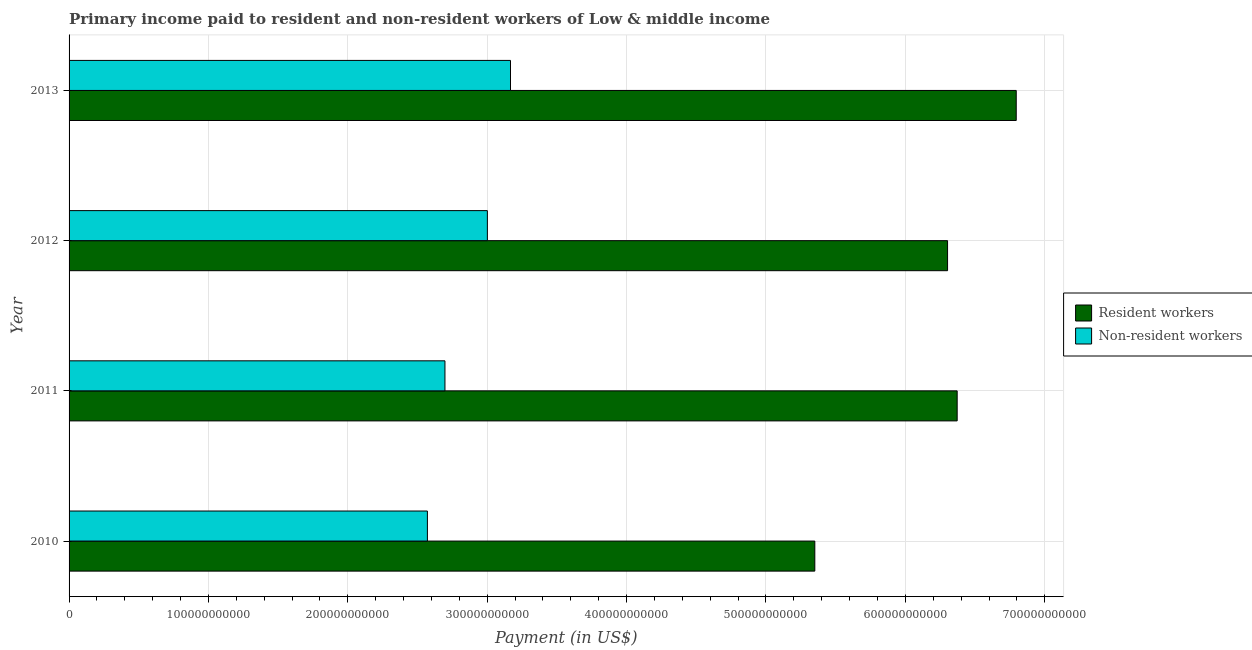How many different coloured bars are there?
Your answer should be very brief. 2. Are the number of bars per tick equal to the number of legend labels?
Offer a very short reply. Yes. Are the number of bars on each tick of the Y-axis equal?
Provide a short and direct response. Yes. How many bars are there on the 3rd tick from the top?
Provide a succinct answer. 2. In how many cases, is the number of bars for a given year not equal to the number of legend labels?
Your answer should be compact. 0. What is the payment made to non-resident workers in 2011?
Make the answer very short. 2.70e+11. Across all years, what is the maximum payment made to non-resident workers?
Ensure brevity in your answer.  3.17e+11. Across all years, what is the minimum payment made to resident workers?
Ensure brevity in your answer.  5.35e+11. In which year was the payment made to non-resident workers maximum?
Give a very brief answer. 2013. In which year was the payment made to non-resident workers minimum?
Your answer should be compact. 2010. What is the total payment made to non-resident workers in the graph?
Your answer should be very brief. 1.14e+12. What is the difference between the payment made to non-resident workers in 2012 and that in 2013?
Your answer should be very brief. -1.66e+1. What is the difference between the payment made to non-resident workers in 2010 and the payment made to resident workers in 2011?
Your answer should be compact. -3.80e+11. What is the average payment made to non-resident workers per year?
Offer a very short reply. 2.86e+11. In the year 2010, what is the difference between the payment made to resident workers and payment made to non-resident workers?
Your answer should be very brief. 2.78e+11. In how many years, is the payment made to resident workers greater than 520000000000 US$?
Provide a short and direct response. 4. What is the ratio of the payment made to non-resident workers in 2010 to that in 2011?
Ensure brevity in your answer.  0.95. Is the payment made to non-resident workers in 2010 less than that in 2013?
Your answer should be compact. Yes. What is the difference between the highest and the second highest payment made to resident workers?
Make the answer very short. 4.24e+1. What is the difference between the highest and the lowest payment made to non-resident workers?
Give a very brief answer. 5.96e+1. In how many years, is the payment made to resident workers greater than the average payment made to resident workers taken over all years?
Give a very brief answer. 3. What does the 1st bar from the top in 2011 represents?
Make the answer very short. Non-resident workers. What does the 1st bar from the bottom in 2010 represents?
Provide a short and direct response. Resident workers. How many bars are there?
Your response must be concise. 8. Are all the bars in the graph horizontal?
Provide a succinct answer. Yes. What is the difference between two consecutive major ticks on the X-axis?
Give a very brief answer. 1.00e+11. Where does the legend appear in the graph?
Your response must be concise. Center right. How many legend labels are there?
Ensure brevity in your answer.  2. How are the legend labels stacked?
Give a very brief answer. Vertical. What is the title of the graph?
Give a very brief answer. Primary income paid to resident and non-resident workers of Low & middle income. What is the label or title of the X-axis?
Your response must be concise. Payment (in US$). What is the label or title of the Y-axis?
Give a very brief answer. Year. What is the Payment (in US$) in Resident workers in 2010?
Offer a very short reply. 5.35e+11. What is the Payment (in US$) in Non-resident workers in 2010?
Your answer should be compact. 2.57e+11. What is the Payment (in US$) in Resident workers in 2011?
Offer a very short reply. 6.37e+11. What is the Payment (in US$) in Non-resident workers in 2011?
Keep it short and to the point. 2.70e+11. What is the Payment (in US$) in Resident workers in 2012?
Your answer should be compact. 6.30e+11. What is the Payment (in US$) in Non-resident workers in 2012?
Offer a terse response. 3.00e+11. What is the Payment (in US$) of Resident workers in 2013?
Keep it short and to the point. 6.80e+11. What is the Payment (in US$) in Non-resident workers in 2013?
Give a very brief answer. 3.17e+11. Across all years, what is the maximum Payment (in US$) in Resident workers?
Make the answer very short. 6.80e+11. Across all years, what is the maximum Payment (in US$) of Non-resident workers?
Your response must be concise. 3.17e+11. Across all years, what is the minimum Payment (in US$) in Resident workers?
Offer a terse response. 5.35e+11. Across all years, what is the minimum Payment (in US$) of Non-resident workers?
Ensure brevity in your answer.  2.57e+11. What is the total Payment (in US$) of Resident workers in the graph?
Provide a short and direct response. 2.48e+12. What is the total Payment (in US$) in Non-resident workers in the graph?
Make the answer very short. 1.14e+12. What is the difference between the Payment (in US$) of Resident workers in 2010 and that in 2011?
Give a very brief answer. -1.02e+11. What is the difference between the Payment (in US$) of Non-resident workers in 2010 and that in 2011?
Offer a very short reply. -1.26e+1. What is the difference between the Payment (in US$) in Resident workers in 2010 and that in 2012?
Your answer should be very brief. -9.52e+1. What is the difference between the Payment (in US$) of Non-resident workers in 2010 and that in 2012?
Your answer should be very brief. -4.30e+1. What is the difference between the Payment (in US$) of Resident workers in 2010 and that in 2013?
Ensure brevity in your answer.  -1.45e+11. What is the difference between the Payment (in US$) in Non-resident workers in 2010 and that in 2013?
Keep it short and to the point. -5.96e+1. What is the difference between the Payment (in US$) of Resident workers in 2011 and that in 2012?
Provide a short and direct response. 6.90e+09. What is the difference between the Payment (in US$) of Non-resident workers in 2011 and that in 2012?
Offer a terse response. -3.04e+1. What is the difference between the Payment (in US$) of Resident workers in 2011 and that in 2013?
Offer a very short reply. -4.24e+1. What is the difference between the Payment (in US$) of Non-resident workers in 2011 and that in 2013?
Provide a succinct answer. -4.70e+1. What is the difference between the Payment (in US$) in Resident workers in 2012 and that in 2013?
Make the answer very short. -4.93e+1. What is the difference between the Payment (in US$) of Non-resident workers in 2012 and that in 2013?
Provide a short and direct response. -1.66e+1. What is the difference between the Payment (in US$) of Resident workers in 2010 and the Payment (in US$) of Non-resident workers in 2011?
Offer a very short reply. 2.65e+11. What is the difference between the Payment (in US$) of Resident workers in 2010 and the Payment (in US$) of Non-resident workers in 2012?
Provide a short and direct response. 2.35e+11. What is the difference between the Payment (in US$) in Resident workers in 2010 and the Payment (in US$) in Non-resident workers in 2013?
Provide a short and direct response. 2.18e+11. What is the difference between the Payment (in US$) in Resident workers in 2011 and the Payment (in US$) in Non-resident workers in 2012?
Give a very brief answer. 3.37e+11. What is the difference between the Payment (in US$) of Resident workers in 2011 and the Payment (in US$) of Non-resident workers in 2013?
Provide a succinct answer. 3.20e+11. What is the difference between the Payment (in US$) in Resident workers in 2012 and the Payment (in US$) in Non-resident workers in 2013?
Your answer should be very brief. 3.14e+11. What is the average Payment (in US$) of Resident workers per year?
Make the answer very short. 6.21e+11. What is the average Payment (in US$) in Non-resident workers per year?
Provide a short and direct response. 2.86e+11. In the year 2010, what is the difference between the Payment (in US$) in Resident workers and Payment (in US$) in Non-resident workers?
Provide a short and direct response. 2.78e+11. In the year 2011, what is the difference between the Payment (in US$) of Resident workers and Payment (in US$) of Non-resident workers?
Make the answer very short. 3.67e+11. In the year 2012, what is the difference between the Payment (in US$) of Resident workers and Payment (in US$) of Non-resident workers?
Offer a terse response. 3.30e+11. In the year 2013, what is the difference between the Payment (in US$) of Resident workers and Payment (in US$) of Non-resident workers?
Your response must be concise. 3.63e+11. What is the ratio of the Payment (in US$) of Resident workers in 2010 to that in 2011?
Ensure brevity in your answer.  0.84. What is the ratio of the Payment (in US$) in Non-resident workers in 2010 to that in 2011?
Offer a very short reply. 0.95. What is the ratio of the Payment (in US$) of Resident workers in 2010 to that in 2012?
Offer a terse response. 0.85. What is the ratio of the Payment (in US$) of Non-resident workers in 2010 to that in 2012?
Your answer should be compact. 0.86. What is the ratio of the Payment (in US$) in Resident workers in 2010 to that in 2013?
Your answer should be compact. 0.79. What is the ratio of the Payment (in US$) of Non-resident workers in 2010 to that in 2013?
Offer a very short reply. 0.81. What is the ratio of the Payment (in US$) in Resident workers in 2011 to that in 2012?
Make the answer very short. 1.01. What is the ratio of the Payment (in US$) of Non-resident workers in 2011 to that in 2012?
Make the answer very short. 0.9. What is the ratio of the Payment (in US$) of Resident workers in 2011 to that in 2013?
Your response must be concise. 0.94. What is the ratio of the Payment (in US$) of Non-resident workers in 2011 to that in 2013?
Offer a terse response. 0.85. What is the ratio of the Payment (in US$) in Resident workers in 2012 to that in 2013?
Your answer should be compact. 0.93. What is the ratio of the Payment (in US$) in Non-resident workers in 2012 to that in 2013?
Give a very brief answer. 0.95. What is the difference between the highest and the second highest Payment (in US$) of Resident workers?
Your response must be concise. 4.24e+1. What is the difference between the highest and the second highest Payment (in US$) of Non-resident workers?
Your answer should be very brief. 1.66e+1. What is the difference between the highest and the lowest Payment (in US$) of Resident workers?
Make the answer very short. 1.45e+11. What is the difference between the highest and the lowest Payment (in US$) of Non-resident workers?
Your answer should be compact. 5.96e+1. 